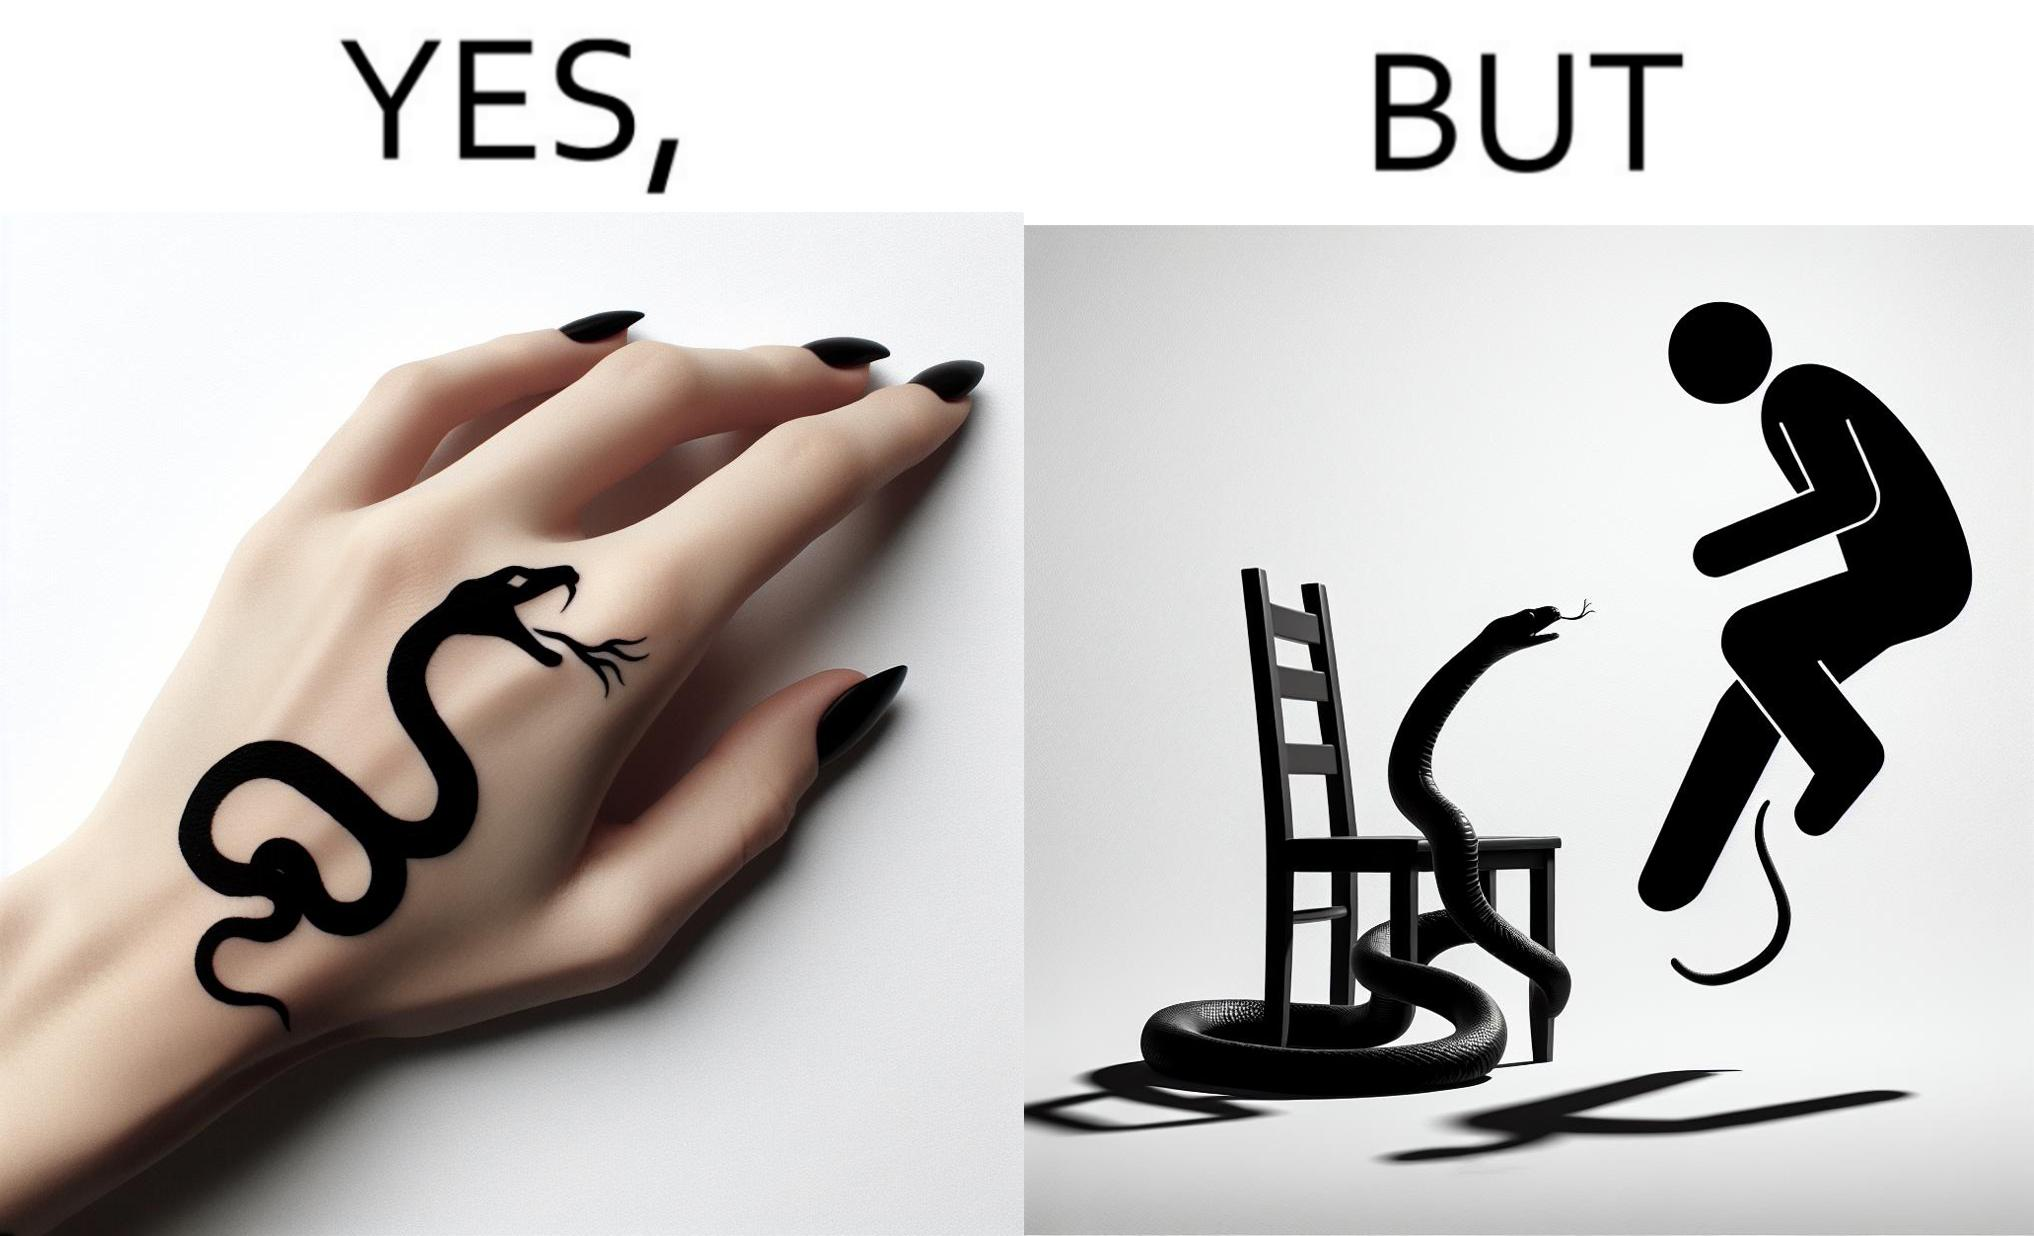What is the satirical meaning behind this image? The image is ironic, because in the first image the tattoo of a snake on someone's hand may give us a hint about how powerful or brave the person can be who is having this tattoo but in the second image the person with same tattoo is seen frightened due to a snake in his house 